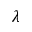<formula> <loc_0><loc_0><loc_500><loc_500>\lambda</formula> 